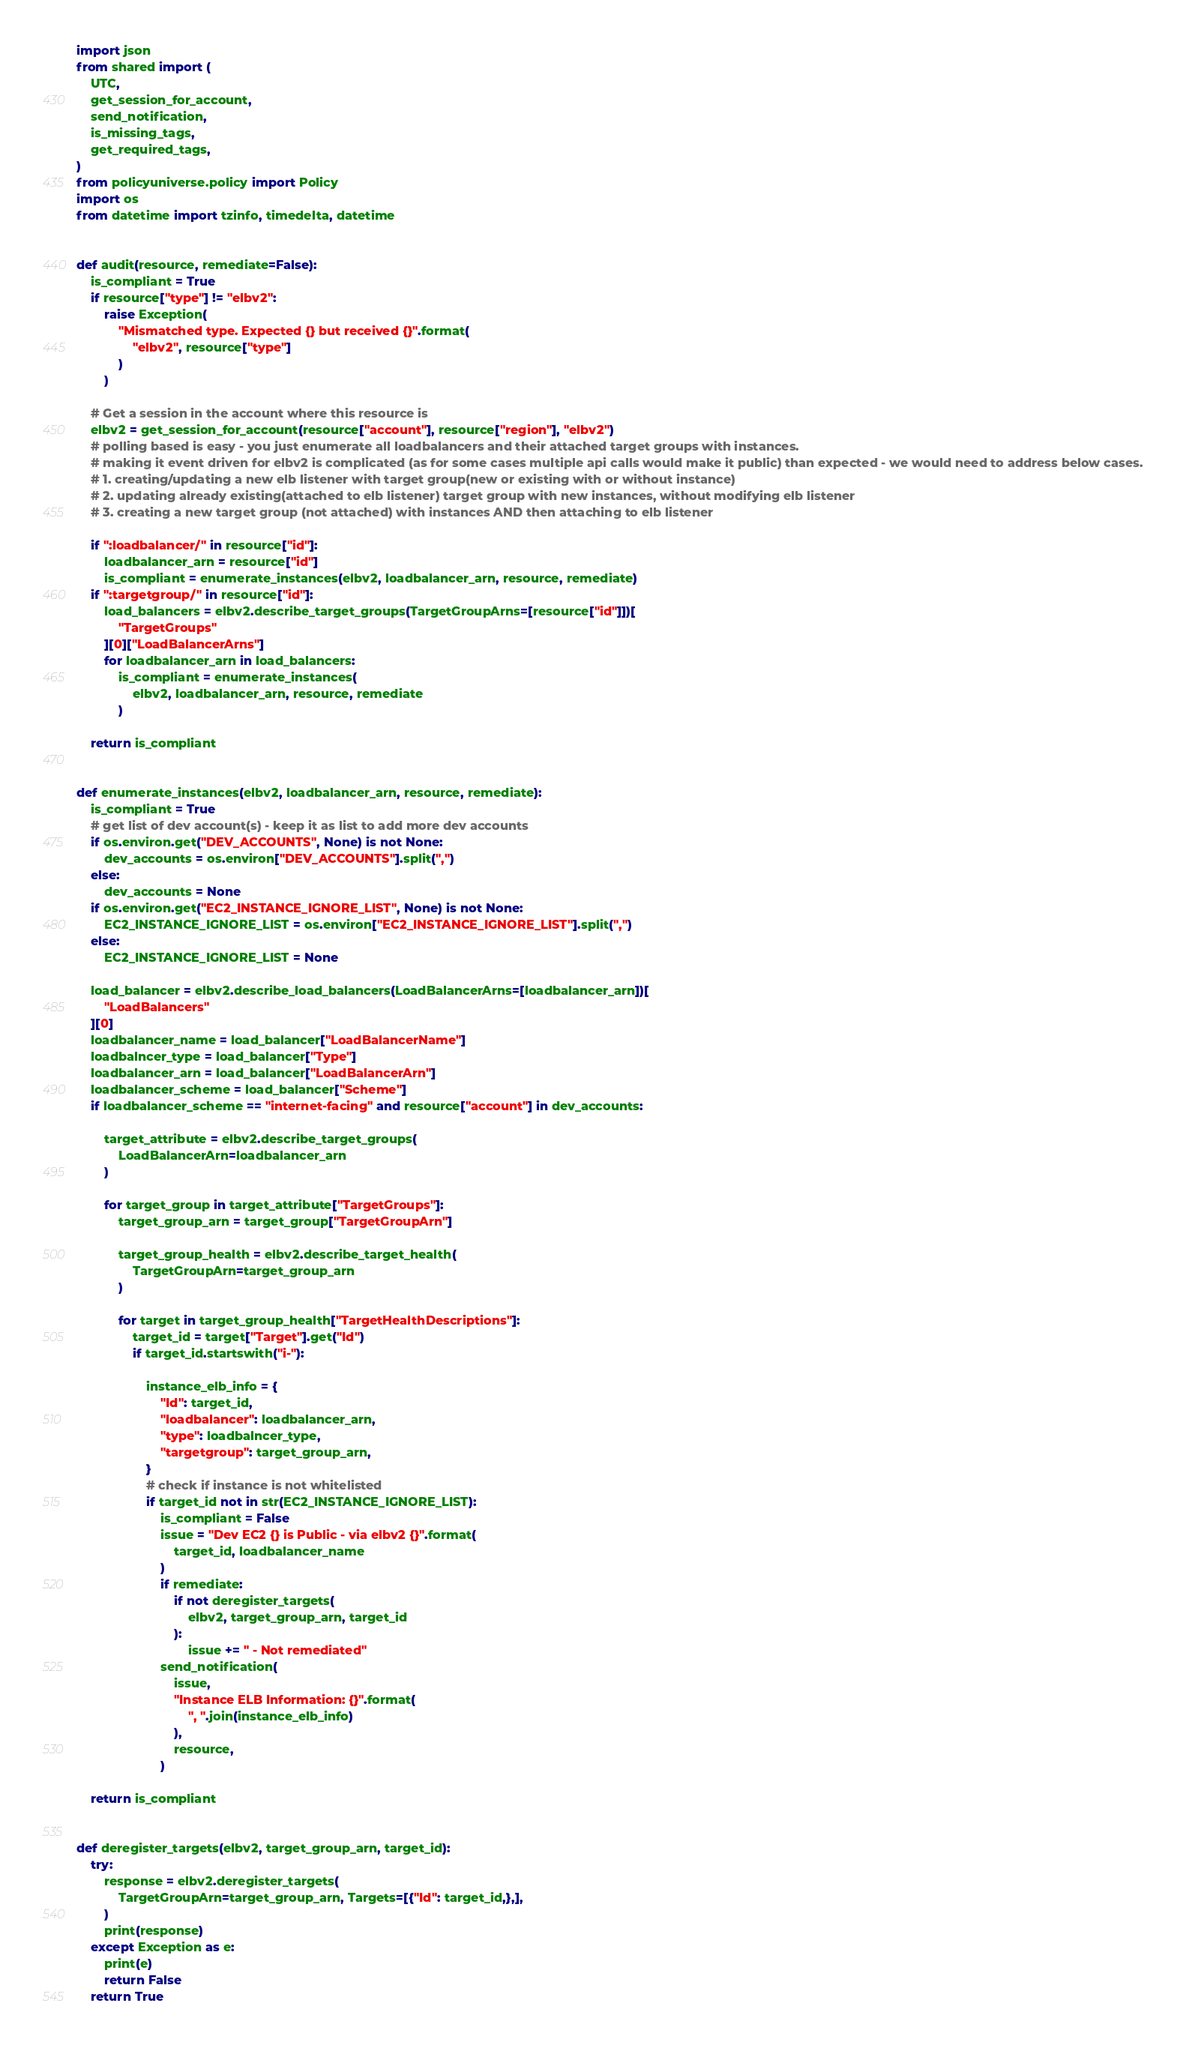<code> <loc_0><loc_0><loc_500><loc_500><_Python_>import json
from shared import (
    UTC,
    get_session_for_account,
    send_notification,
    is_missing_tags,
    get_required_tags,
)
from policyuniverse.policy import Policy
import os
from datetime import tzinfo, timedelta, datetime


def audit(resource, remediate=False):
    is_compliant = True
    if resource["type"] != "elbv2":
        raise Exception(
            "Mismatched type. Expected {} but received {}".format(
                "elbv2", resource["type"]
            )
        )

    # Get a session in the account where this resource is
    elbv2 = get_session_for_account(resource["account"], resource["region"], "elbv2")
    # polling based is easy - you just enumerate all loadbalancers and their attached target groups with instances.
    # making it event driven for elbv2 is complicated (as for some cases multiple api calls would make it public) than expected - we would need to address below cases.
    # 1. creating/updating a new elb listener with target group(new or existing with or without instance)
    # 2. updating already existing(attached to elb listener) target group with new instances, without modifying elb listener
    # 3. creating a new target group (not attached) with instances AND then attaching to elb listener

    if ":loadbalancer/" in resource["id"]:
        loadbalancer_arn = resource["id"]
        is_compliant = enumerate_instances(elbv2, loadbalancer_arn, resource, remediate)
    if ":targetgroup/" in resource["id"]:
        load_balancers = elbv2.describe_target_groups(TargetGroupArns=[resource["id"]])[
            "TargetGroups"
        ][0]["LoadBalancerArns"]
        for loadbalancer_arn in load_balancers:
            is_compliant = enumerate_instances(
                elbv2, loadbalancer_arn, resource, remediate
            )

    return is_compliant


def enumerate_instances(elbv2, loadbalancer_arn, resource, remediate):
    is_compliant = True
    # get list of dev account(s) - keep it as list to add more dev accounts
    if os.environ.get("DEV_ACCOUNTS", None) is not None:
        dev_accounts = os.environ["DEV_ACCOUNTS"].split(",")
    else:
        dev_accounts = None
    if os.environ.get("EC2_INSTANCE_IGNORE_LIST", None) is not None:
        EC2_INSTANCE_IGNORE_LIST = os.environ["EC2_INSTANCE_IGNORE_LIST"].split(",")
    else:
        EC2_INSTANCE_IGNORE_LIST = None

    load_balancer = elbv2.describe_load_balancers(LoadBalancerArns=[loadbalancer_arn])[
        "LoadBalancers"
    ][0]
    loadbalancer_name = load_balancer["LoadBalancerName"]
    loadbalncer_type = load_balancer["Type"]
    loadbalancer_arn = load_balancer["LoadBalancerArn"]
    loadbalancer_scheme = load_balancer["Scheme"]
    if loadbalancer_scheme == "internet-facing" and resource["account"] in dev_accounts:

        target_attribute = elbv2.describe_target_groups(
            LoadBalancerArn=loadbalancer_arn
        )

        for target_group in target_attribute["TargetGroups"]:
            target_group_arn = target_group["TargetGroupArn"]

            target_group_health = elbv2.describe_target_health(
                TargetGroupArn=target_group_arn
            )

            for target in target_group_health["TargetHealthDescriptions"]:
                target_id = target["Target"].get("Id")
                if target_id.startswith("i-"):

                    instance_elb_info = {
                        "Id": target_id,
                        "loadbalancer": loadbalancer_arn,
                        "type": loadbalncer_type,
                        "targetgroup": target_group_arn,
                    }
                    # check if instance is not whitelisted
                    if target_id not in str(EC2_INSTANCE_IGNORE_LIST):
                        is_compliant = False
                        issue = "Dev EC2 {} is Public - via elbv2 {}".format(
                            target_id, loadbalancer_name
                        )
                        if remediate:
                            if not deregister_targets(
                                elbv2, target_group_arn, target_id
                            ):
                                issue += " - Not remediated"
                        send_notification(
                            issue,
                            "Instance ELB Information: {}".format(
                                ", ".join(instance_elb_info)
                            ),
                            resource,
                        )

    return is_compliant


def deregister_targets(elbv2, target_group_arn, target_id):
    try:
        response = elbv2.deregister_targets(
            TargetGroupArn=target_group_arn, Targets=[{"Id": target_id,},],
        )
        print(response)
    except Exception as e:
        print(e)
        return False
    return True
</code> 